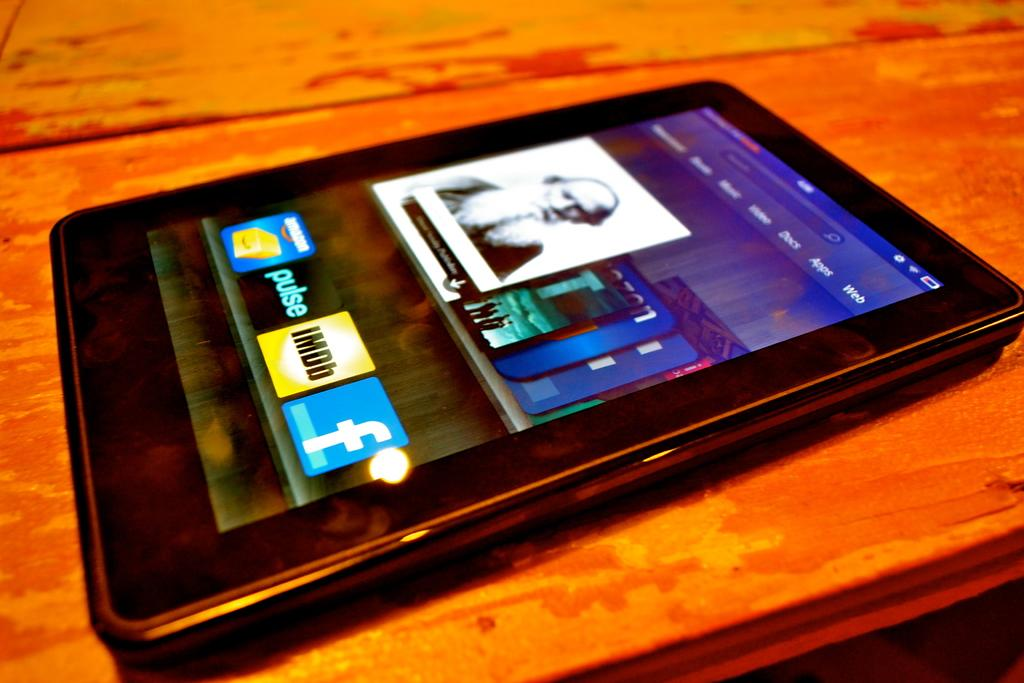What is the main object in the center of the image? There is a table in the center of the image. What is placed on the table? There is a mobile phone on the table. What can be seen on the mobile phone's screen? The mobile phone's screen displays different apps. How many cattle are grazing in the background of the image? There are no cattle present in the image; it only features a table with a mobile phone on it. 